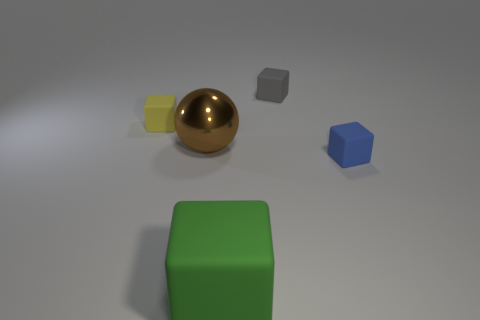Is the number of yellow objects less than the number of small red rubber objects?
Provide a succinct answer. No. Are there any matte objects to the right of the large metal object that is on the left side of the large green rubber block?
Provide a succinct answer. Yes. There is a tiny cube that is in front of the matte cube left of the large brown shiny object; are there any rubber cubes that are in front of it?
Your response must be concise. Yes. Is the shape of the object that is on the right side of the tiny gray matte cube the same as the brown metallic object that is to the left of the gray cube?
Offer a very short reply. No. What is the color of the big thing that is the same material as the small yellow thing?
Ensure brevity in your answer.  Green. Are there fewer blue rubber blocks left of the tiny blue block than large blue balls?
Ensure brevity in your answer.  No. There is a brown shiny ball in front of the matte thing that is on the left side of the rubber cube that is in front of the blue object; how big is it?
Make the answer very short. Large. Does the large thing that is behind the green cube have the same material as the big green cube?
Offer a very short reply. No. Are there any other things that have the same shape as the shiny thing?
Give a very brief answer. No. How many objects are either brown metallic objects or large cyan shiny objects?
Your answer should be very brief. 1. 